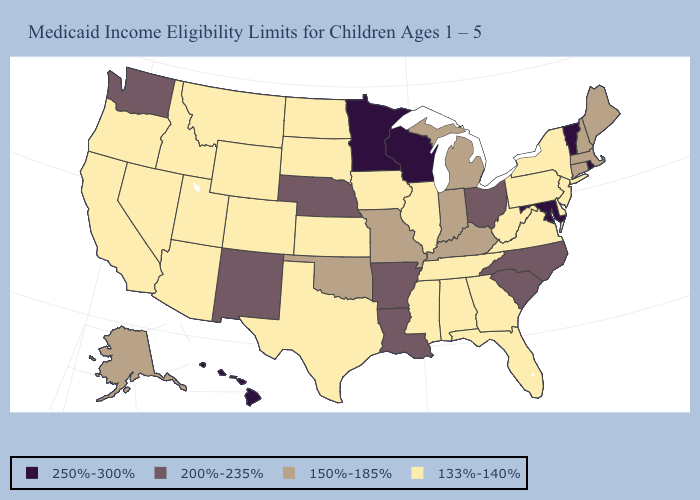Which states have the lowest value in the USA?
Keep it brief. Alabama, Arizona, California, Colorado, Delaware, Florida, Georgia, Idaho, Illinois, Iowa, Kansas, Mississippi, Montana, Nevada, New Jersey, New York, North Dakota, Oregon, Pennsylvania, South Dakota, Tennessee, Texas, Utah, Virginia, West Virginia, Wyoming. Which states have the lowest value in the MidWest?
Short answer required. Illinois, Iowa, Kansas, North Dakota, South Dakota. Among the states that border Louisiana , which have the lowest value?
Answer briefly. Mississippi, Texas. Is the legend a continuous bar?
Be succinct. No. Does Minnesota have the highest value in the USA?
Write a very short answer. Yes. How many symbols are there in the legend?
Give a very brief answer. 4. Which states have the lowest value in the USA?
Give a very brief answer. Alabama, Arizona, California, Colorado, Delaware, Florida, Georgia, Idaho, Illinois, Iowa, Kansas, Mississippi, Montana, Nevada, New Jersey, New York, North Dakota, Oregon, Pennsylvania, South Dakota, Tennessee, Texas, Utah, Virginia, West Virginia, Wyoming. Does North Carolina have the lowest value in the USA?
Short answer required. No. Does Louisiana have the highest value in the USA?
Be succinct. No. What is the highest value in the West ?
Write a very short answer. 250%-300%. What is the highest value in states that border South Carolina?
Answer briefly. 200%-235%. What is the value of Alabama?
Concise answer only. 133%-140%. Name the states that have a value in the range 250%-300%?
Write a very short answer. Hawaii, Maryland, Minnesota, Rhode Island, Vermont, Wisconsin. Does the first symbol in the legend represent the smallest category?
Keep it brief. No. What is the lowest value in the USA?
Keep it brief. 133%-140%. 